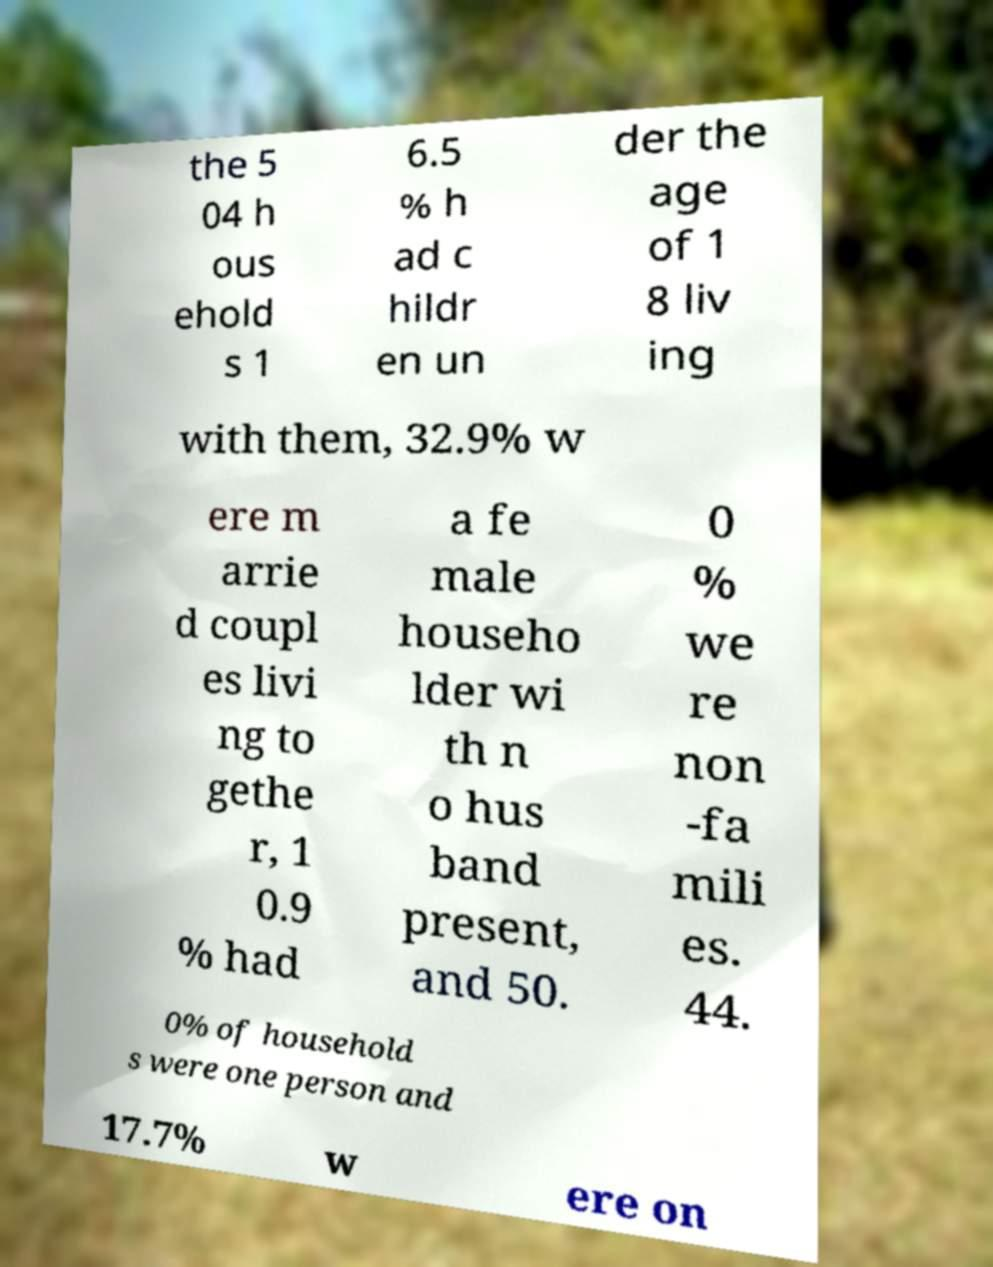Can you read and provide the text displayed in the image?This photo seems to have some interesting text. Can you extract and type it out for me? the 5 04 h ous ehold s 1 6.5 % h ad c hildr en un der the age of 1 8 liv ing with them, 32.9% w ere m arrie d coupl es livi ng to gethe r, 1 0.9 % had a fe male househo lder wi th n o hus band present, and 50. 0 % we re non -fa mili es. 44. 0% of household s were one person and 17.7% w ere on 